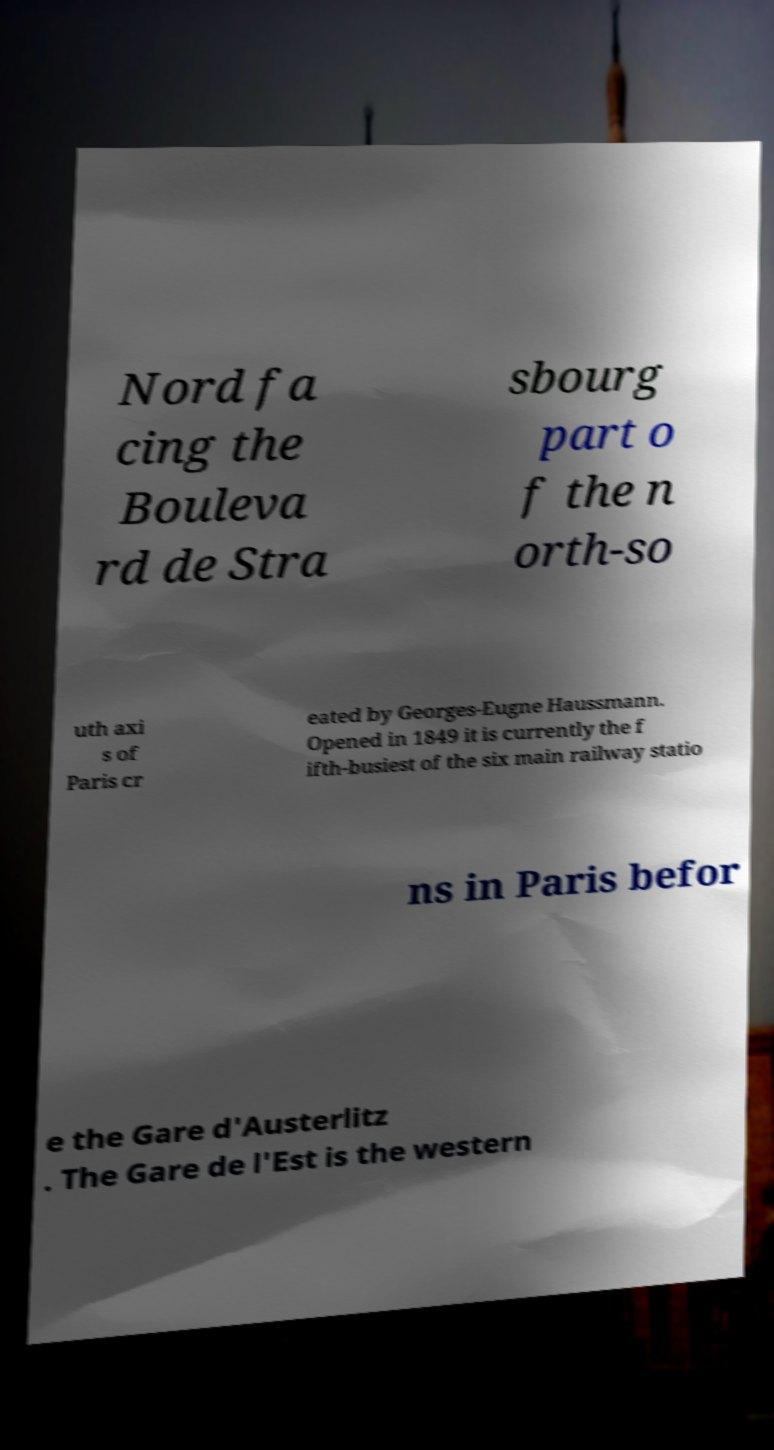Could you assist in decoding the text presented in this image and type it out clearly? Nord fa cing the Bouleva rd de Stra sbourg part o f the n orth-so uth axi s of Paris cr eated by Georges-Eugne Haussmann. Opened in 1849 it is currently the f ifth-busiest of the six main railway statio ns in Paris befor e the Gare d'Austerlitz . The Gare de l'Est is the western 